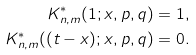<formula> <loc_0><loc_0><loc_500><loc_500>K _ { n , m } ^ { * } ( 1 ; x , p , q ) & = 1 , \\ K _ { n , m } ^ { * } ( ( t - x ) ; x , p , q ) & = 0 .</formula> 